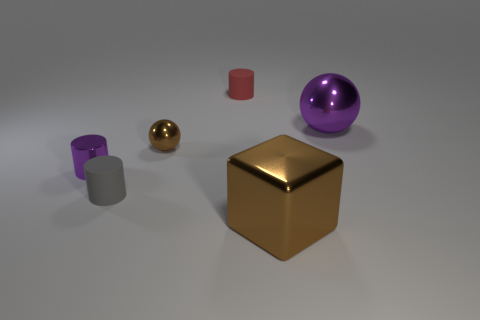How many tiny shiny balls are the same color as the metal block?
Ensure brevity in your answer.  1. What shape is the purple metallic object that is the same size as the brown ball?
Give a very brief answer. Cylinder. Are there any small brown metal balls to the left of the small metal sphere?
Your response must be concise. No. Does the block have the same size as the brown ball?
Ensure brevity in your answer.  No. There is a brown thing that is behind the purple metallic cylinder; what is its shape?
Provide a succinct answer. Sphere. Is there a red rubber thing that has the same size as the gray cylinder?
Your response must be concise. Yes. There is a purple cylinder that is the same size as the gray matte cylinder; what is its material?
Make the answer very short. Metal. How big is the purple shiny thing in front of the big shiny ball?
Offer a terse response. Small. The gray matte thing has what size?
Give a very brief answer. Small. Is the size of the gray thing the same as the metal sphere that is to the left of the large purple metallic ball?
Your answer should be very brief. Yes. 